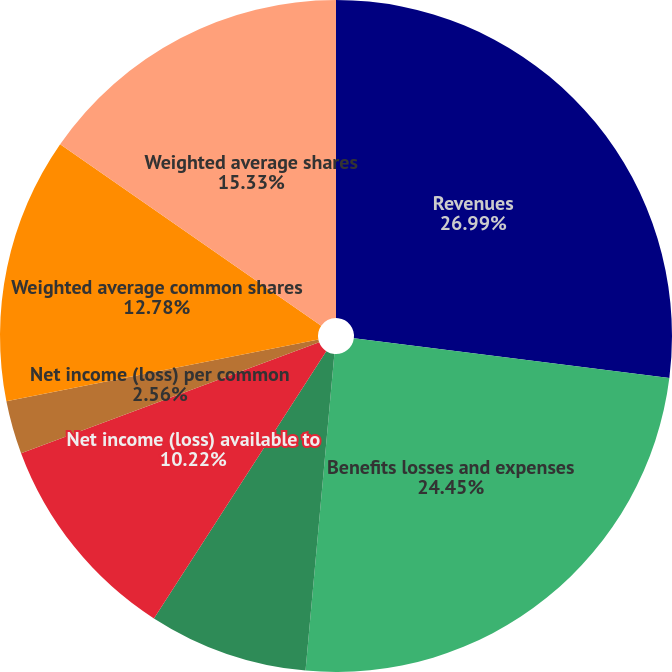Convert chart to OTSL. <chart><loc_0><loc_0><loc_500><loc_500><pie_chart><fcel>Revenues<fcel>Benefits losses and expenses<fcel>Income (loss) from continuing<fcel>Net income (loss)<fcel>Net income (loss) available to<fcel>Net income (loss) per common<fcel>Weighted average common shares<fcel>Weighted average shares<nl><fcel>27.0%<fcel>24.45%<fcel>0.0%<fcel>7.67%<fcel>10.22%<fcel>2.56%<fcel>12.78%<fcel>15.33%<nl></chart> 